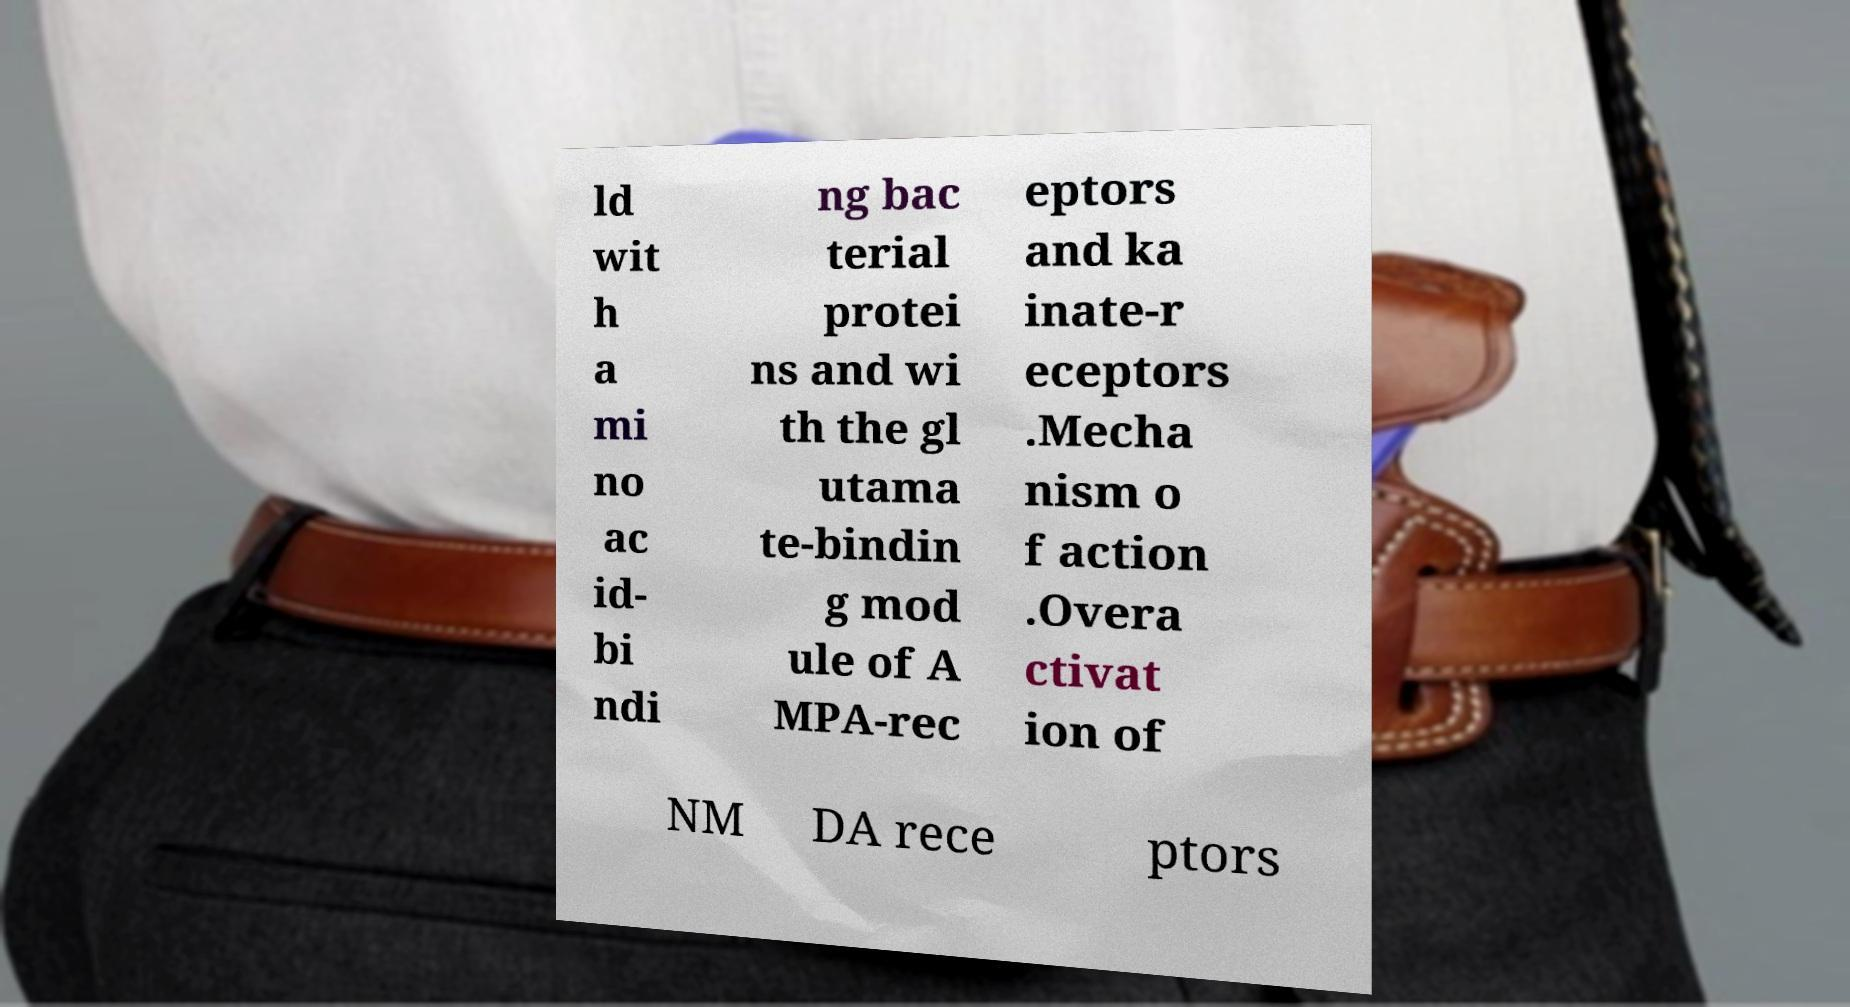What messages or text are displayed in this image? I need them in a readable, typed format. ld wit h a mi no ac id- bi ndi ng bac terial protei ns and wi th the gl utama te-bindin g mod ule of A MPA-rec eptors and ka inate-r eceptors .Mecha nism o f action .Overa ctivat ion of NM DA rece ptors 